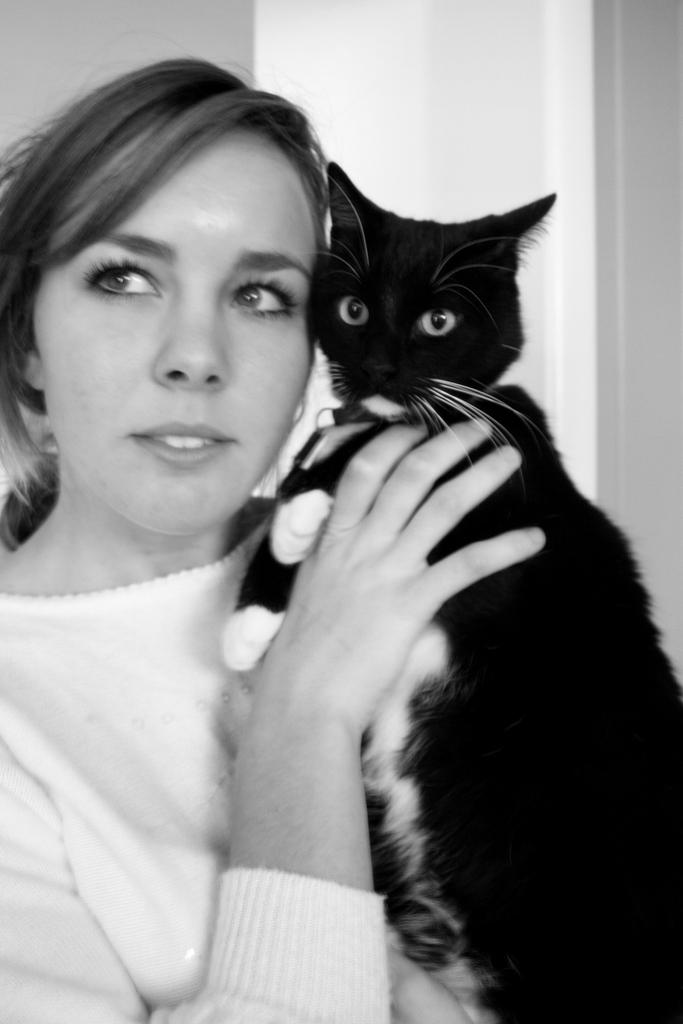Who is the main subject in the image? There is a woman in the image. What is the woman doing in the image? The woman is standing in the image. What is the woman holding in the image? The woman is holding a cat in the image. What can be seen in the background of the image? There is a wall in the background of the image. What type of suit is the committee wearing in the image? There is no committee or suit present in the image; it features a woman holding a cat. 